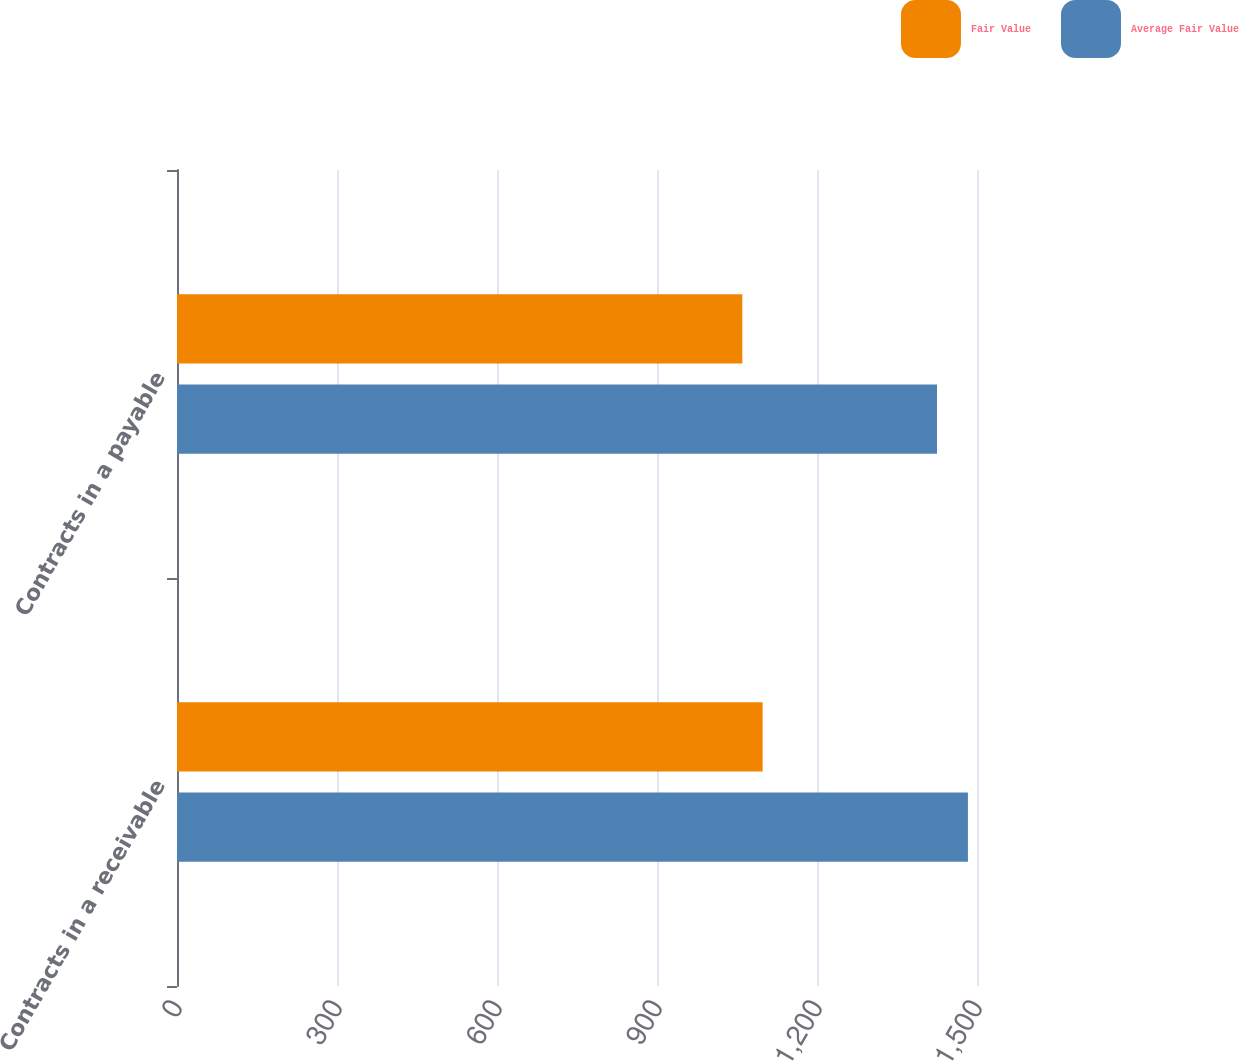Convert chart. <chart><loc_0><loc_0><loc_500><loc_500><stacked_bar_chart><ecel><fcel>Contracts in a receivable<fcel>Contracts in a payable<nl><fcel>Fair Value<fcel>1098<fcel>1060<nl><fcel>Average Fair Value<fcel>1483<fcel>1425<nl></chart> 